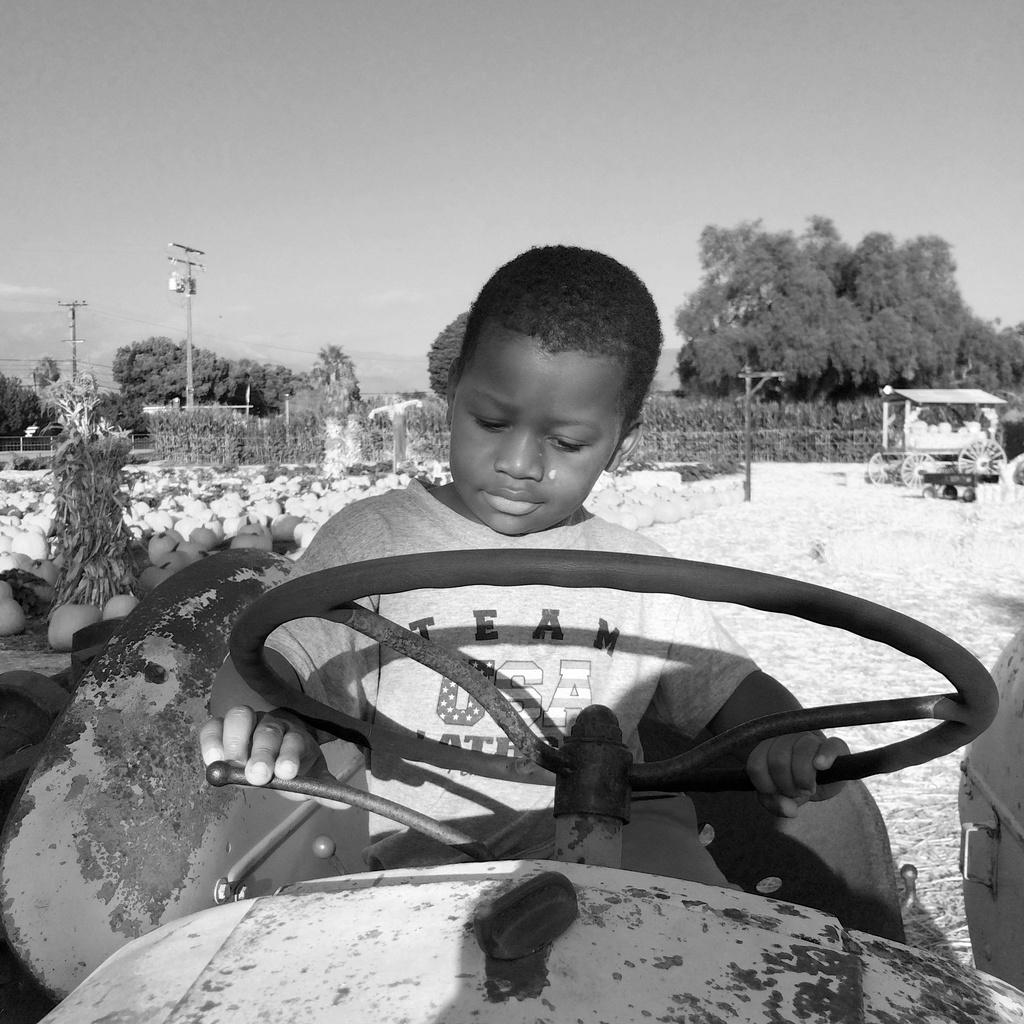What is the kid doing in the image? The kid is sitting on a vehicle and holding a steering wheel. What objects can be seen in the image related to the vehicle? There are pumpkins, plants, poles, and another vehicle visible in the image. What type of ground is visible in the image? The ground is visible in the image, but the specific type of ground cannot be determined from the facts provided. What can be seen in the background of the image? There are trees and the sky visible in the background of the image. What type of tent is set up near the vehicle in the image? There is no tent present in the image. What type of trade is being conducted in the image? There is no indication of any trade being conducted in the image. What type of war is depicted in the image? There is no war depicted in the image. 